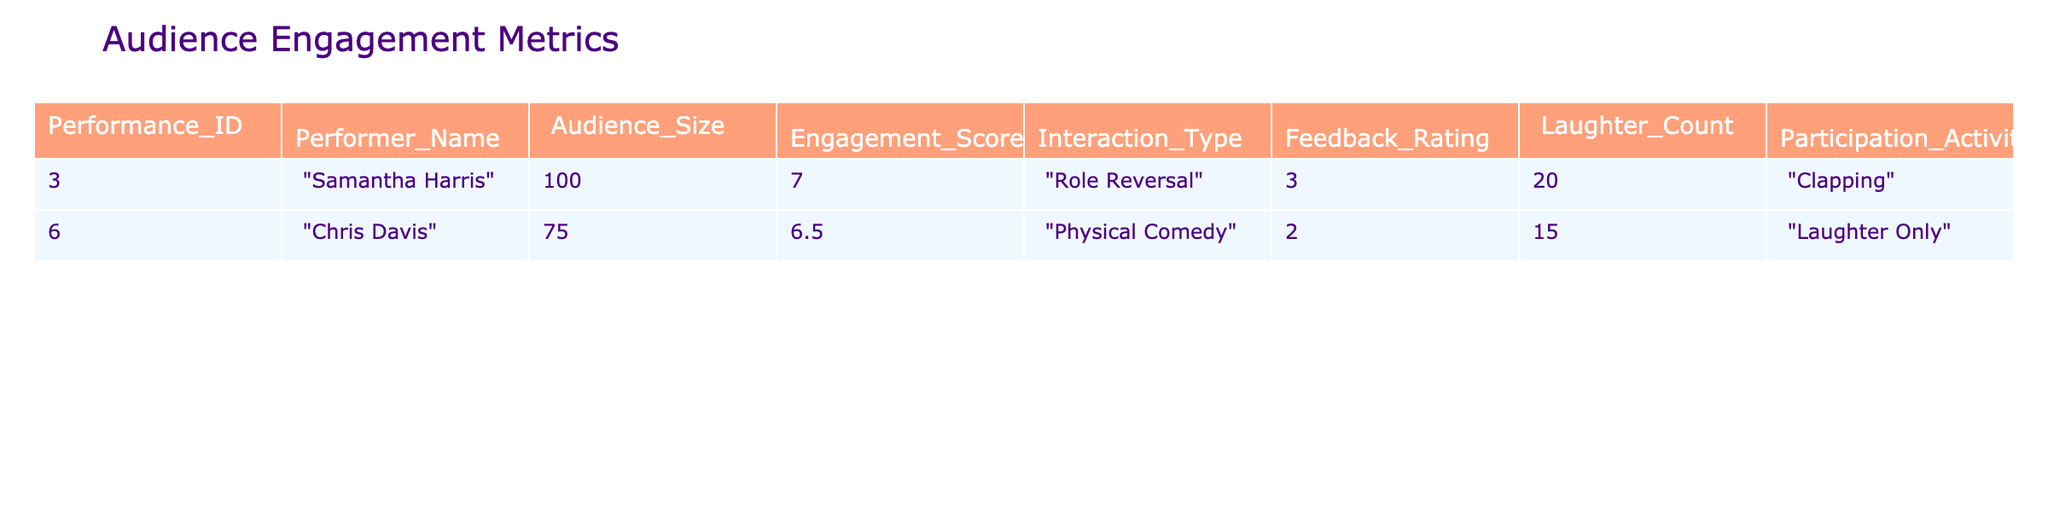What is the Audience Size for Samantha Harris's performance? The table shows that the Audience Size for Samantha Harris is listed under the "Audience_Size" column, which is 100.
Answer: 100 What is Chris Davis's Engagement Score? For Chris Davis, the Engagement Score is provided in the table under the "Engagement_Score" column, which states 6.5.
Answer: 6.5 How many performers have a Laughter Count of 15 or more? By examining the "Laughter_Count" column, I find that only Samantha Harris has a count of 20, while Chris Davis has 15. Thus, there are two performers with a Laughter Count of 15 or greater.
Answer: 2 What is the average Engagement Score of the performances listed? To calculate the average Engagement Score, I sum both scores (7.0 + 6.5 = 13.5) and divide by the number of performers (2), which gives 13.5 / 2 = 6.75.
Answer: 6.75 Did both performers receive a Feedback Rating of 3 or higher? Looking at the "Feedback_Rating" column, Samantha Harris received a rating of 3, while Chris Davis received a 2. Therefore, not both performers meet the criterion.
Answer: No What type of interaction did Chris Davis use during his performance? The table indicates that Chris Davis's Interaction_Type is listed as "Physical Comedy".
Answer: Physical Comedy What is the total Laughter Count across both performances? To find the total Laughter Count, I add the counts from both performers (20 for Samantha Harris and 15 for Chris Davis). So, 20 + 15 = 35.
Answer: 35 Was the Feedback Rating for Samantha Harris higher than that of Chris Davis? In the "Feedback_Rating" column, Samantha Harris has a rating of 3, and Chris Davis has a rating of 2. Since 3 is greater than 2, the statement is true.
Answer: Yes What is the difference in Audience Size between Samantha Harris and Chris Davis? The Audience Size for Samantha Harris is 100 and for Chris Davis is 75. The difference is calculated as 100 - 75 = 25.
Answer: 25 If we look at Participation Activities, which performer engaged in clapping? The table shows that under "Participation_Activities", Samantha Harris's performance involved "Clapping".
Answer: Samantha Harris 